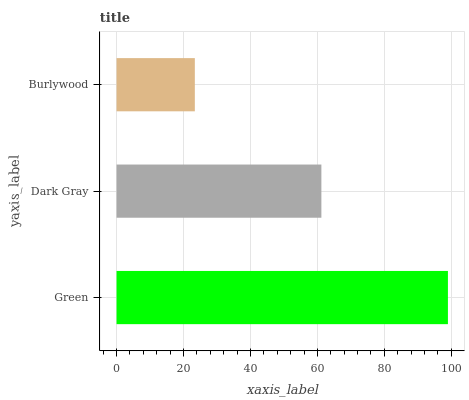Is Burlywood the minimum?
Answer yes or no. Yes. Is Green the maximum?
Answer yes or no. Yes. Is Dark Gray the minimum?
Answer yes or no. No. Is Dark Gray the maximum?
Answer yes or no. No. Is Green greater than Dark Gray?
Answer yes or no. Yes. Is Dark Gray less than Green?
Answer yes or no. Yes. Is Dark Gray greater than Green?
Answer yes or no. No. Is Green less than Dark Gray?
Answer yes or no. No. Is Dark Gray the high median?
Answer yes or no. Yes. Is Dark Gray the low median?
Answer yes or no. Yes. Is Burlywood the high median?
Answer yes or no. No. Is Green the low median?
Answer yes or no. No. 